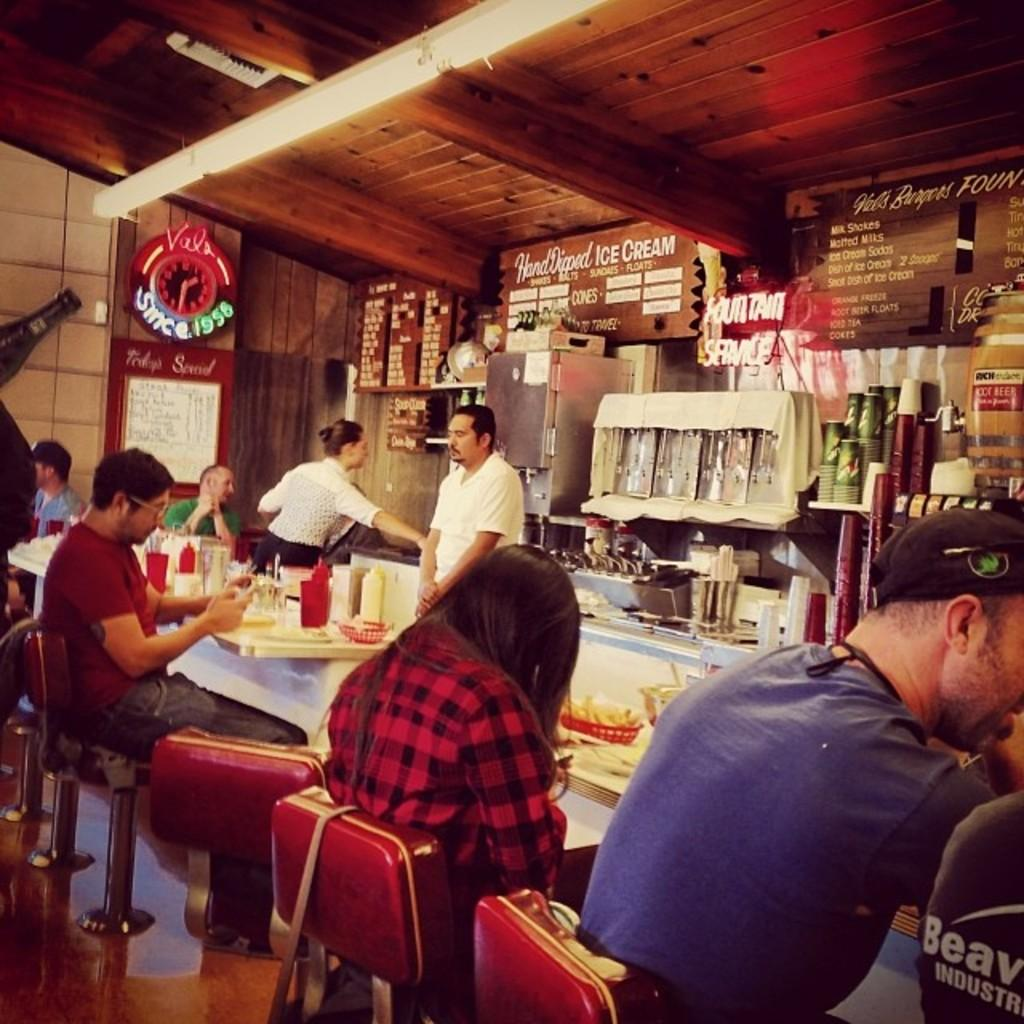What type of establishment is shown in the image? The image depicts a food restaurant. Can you describe the seating arrangement in the restaurant? There are people seated in the restaurant, and they are seated on chairs. What can be seen on the tables in the image? There are food items on the table. What type of pump is visible in the image? There is no pump present in the image. How many stalks of celery are on the table in the image? There is no celery visible in the image; only food items are present on the table. 